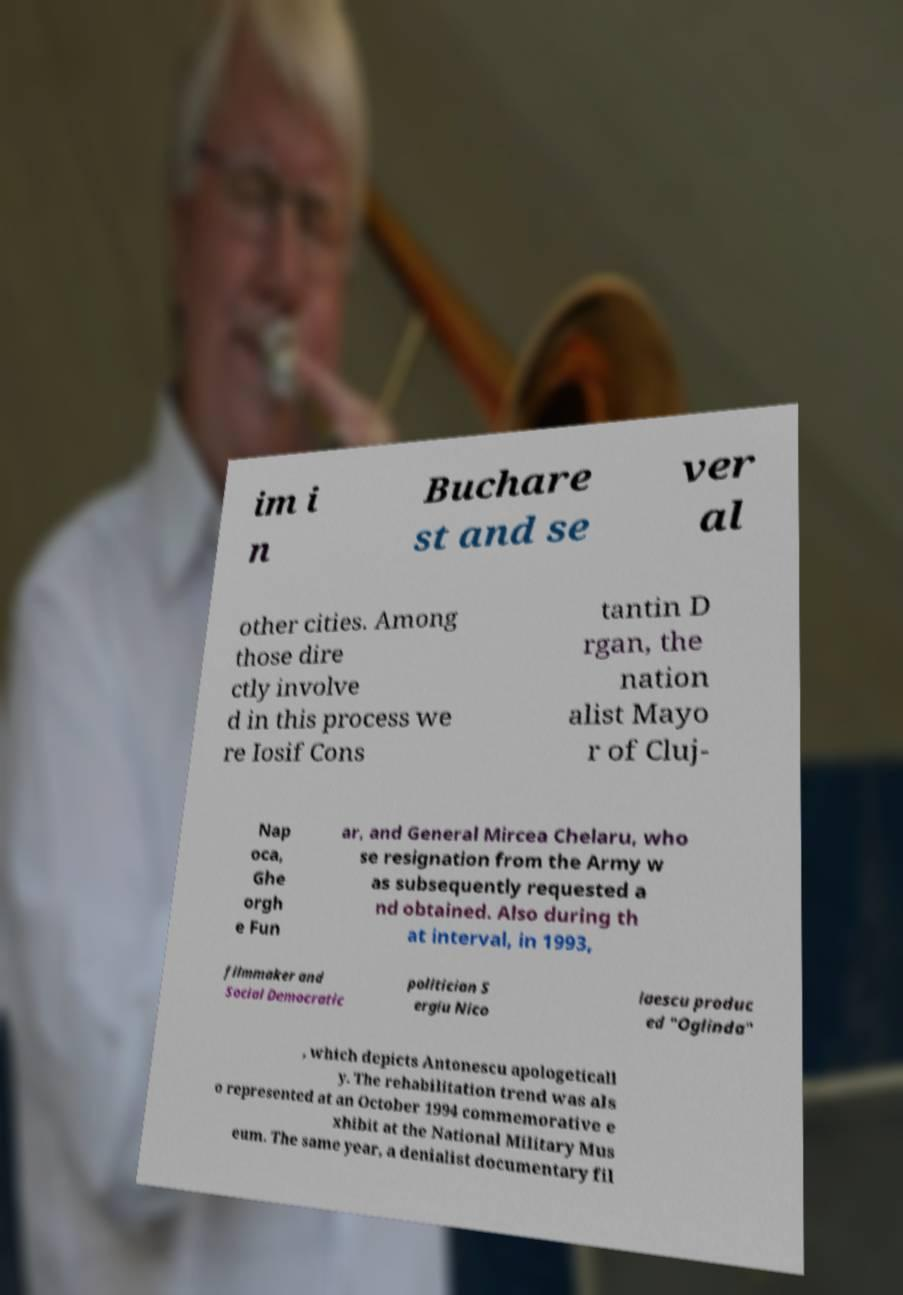What messages or text are displayed in this image? I need them in a readable, typed format. im i n Buchare st and se ver al other cities. Among those dire ctly involve d in this process we re Iosif Cons tantin D rgan, the nation alist Mayo r of Cluj- Nap oca, Ghe orgh e Fun ar, and General Mircea Chelaru, who se resignation from the Army w as subsequently requested a nd obtained. Also during th at interval, in 1993, filmmaker and Social Democratic politician S ergiu Nico laescu produc ed "Oglinda" , which depicts Antonescu apologeticall y. The rehabilitation trend was als o represented at an October 1994 commemorative e xhibit at the National Military Mus eum. The same year, a denialist documentary fil 